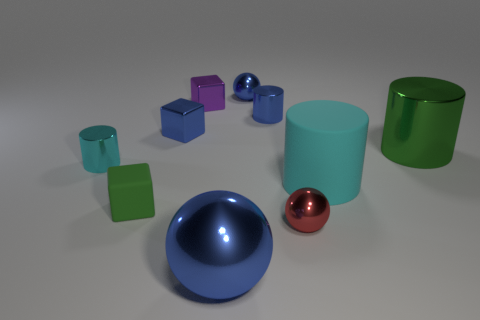What number of purple things are either metal cylinders or metal blocks?
Your answer should be very brief. 1. Is the color of the metallic cylinder on the left side of the rubber block the same as the large matte cylinder?
Your answer should be compact. Yes. There is a red thing that is the same material as the small blue cylinder; what is its shape?
Provide a succinct answer. Sphere. The tiny object that is both to the right of the small green rubber thing and in front of the big metallic cylinder is what color?
Your answer should be compact. Red. How big is the blue shiny sphere that is behind the shiny cube on the left side of the small purple thing?
Make the answer very short. Small. Is there a thing that has the same color as the big metal ball?
Your answer should be very brief. Yes. Are there the same number of shiny cubes that are to the left of the small cyan metal object and brown metallic balls?
Make the answer very short. Yes. What number of big red things are there?
Ensure brevity in your answer.  0. What is the shape of the small object that is both in front of the cyan shiny cylinder and left of the tiny blue cylinder?
Make the answer very short. Cube. Is the color of the small cylinder right of the large ball the same as the shiny block to the left of the purple thing?
Offer a terse response. Yes. 